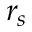<formula> <loc_0><loc_0><loc_500><loc_500>r _ { s }</formula> 